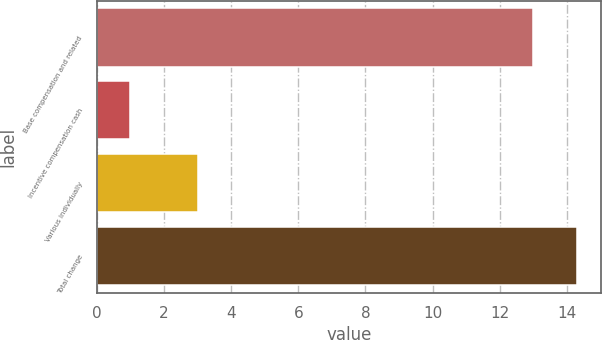<chart> <loc_0><loc_0><loc_500><loc_500><bar_chart><fcel>Base compensation and related<fcel>Incentive compensation cash<fcel>Various individually<fcel>Total change<nl><fcel>13<fcel>1<fcel>3<fcel>14.3<nl></chart> 